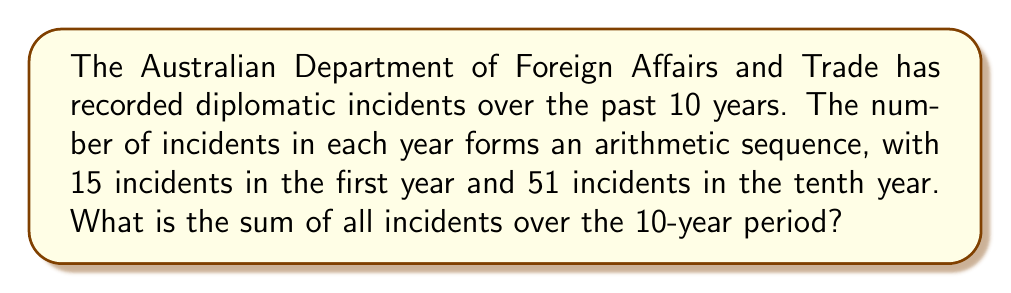Can you solve this math problem? Let's approach this step-by-step:

1) In an arithmetic sequence, the difference between each term is constant. Let's call this common difference $d$.

2) We know the first term $a_1 = 15$ and the tenth term $a_{10} = 51$.

3) In an arithmetic sequence, the nth term is given by:
   $a_n = a_1 + (n-1)d$

4) Using this for the 10th term:
   $51 = 15 + (10-1)d$
   $51 = 15 + 9d$
   $36 = 9d$
   $d = 4$

5) Now we know the sequence starts at 15 and increases by 4 each year.

6) To find the sum of an arithmetic sequence, we can use the formula:
   $S_n = \frac{n}{2}(a_1 + a_n)$
   where $n$ is the number of terms, $a_1$ is the first term, and $a_n$ is the last term.

7) Substituting our values:
   $S_{10} = \frac{10}{2}(15 + 51)$
   $S_{10} = 5(66)$
   $S_{10} = 330$

Therefore, the sum of all incidents over the 10-year period is 330.
Answer: 330 